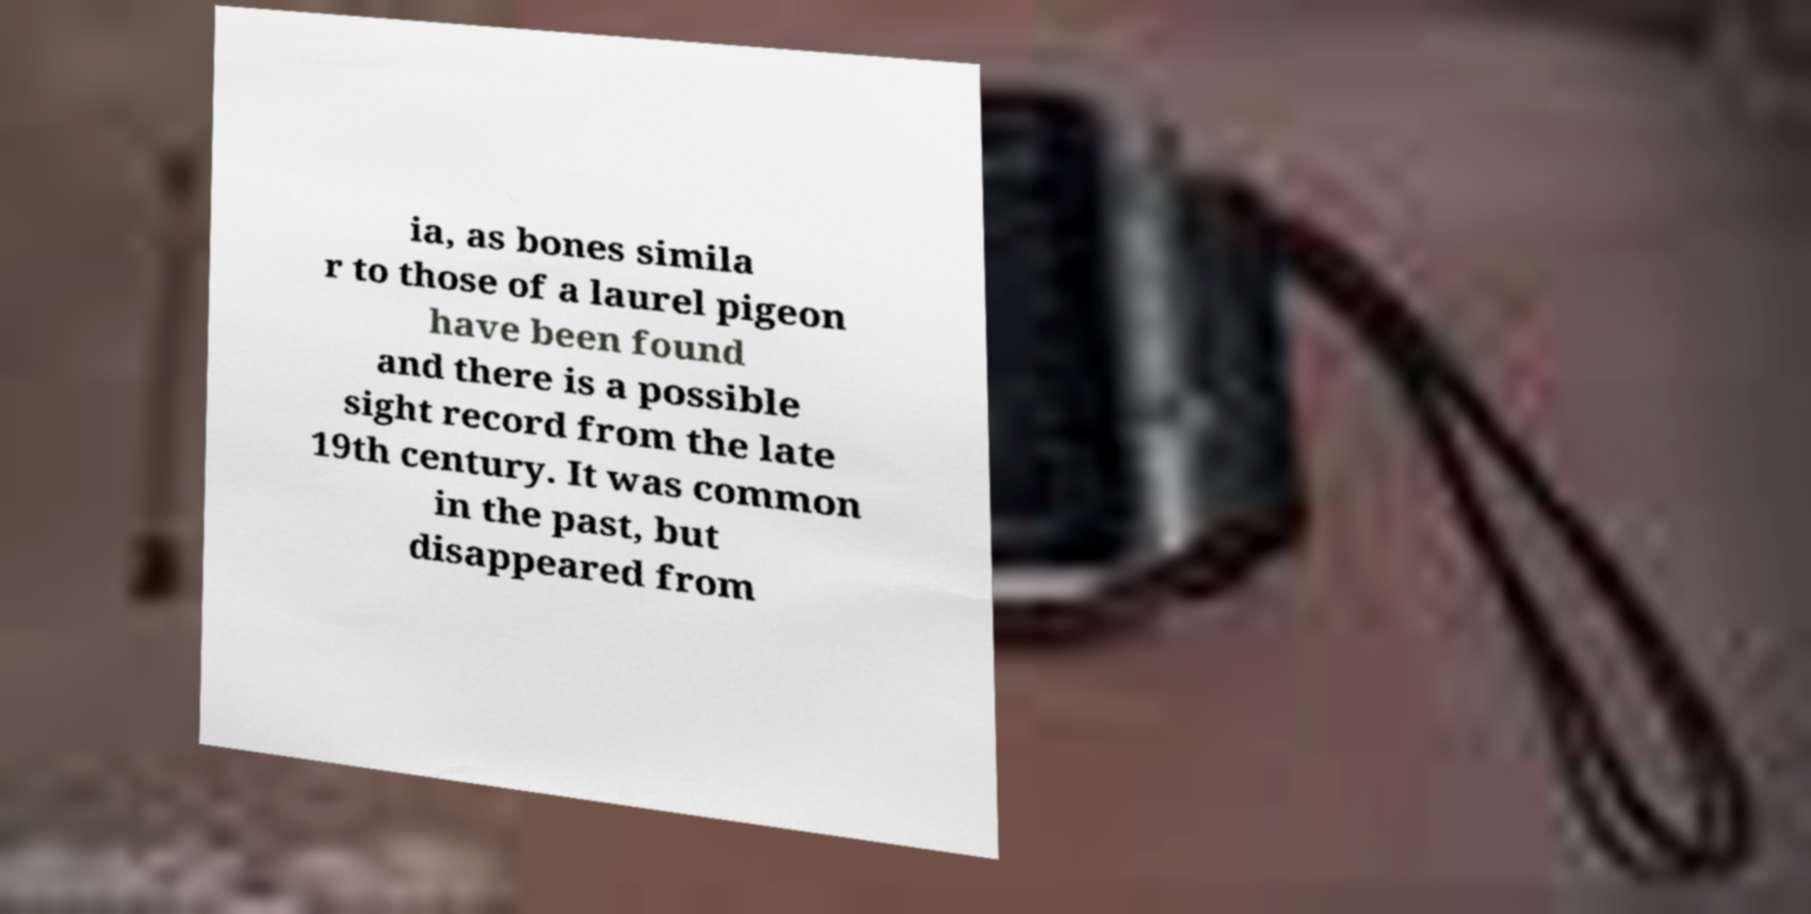What messages or text are displayed in this image? I need them in a readable, typed format. ia, as bones simila r to those of a laurel pigeon have been found and there is a possible sight record from the late 19th century. It was common in the past, but disappeared from 